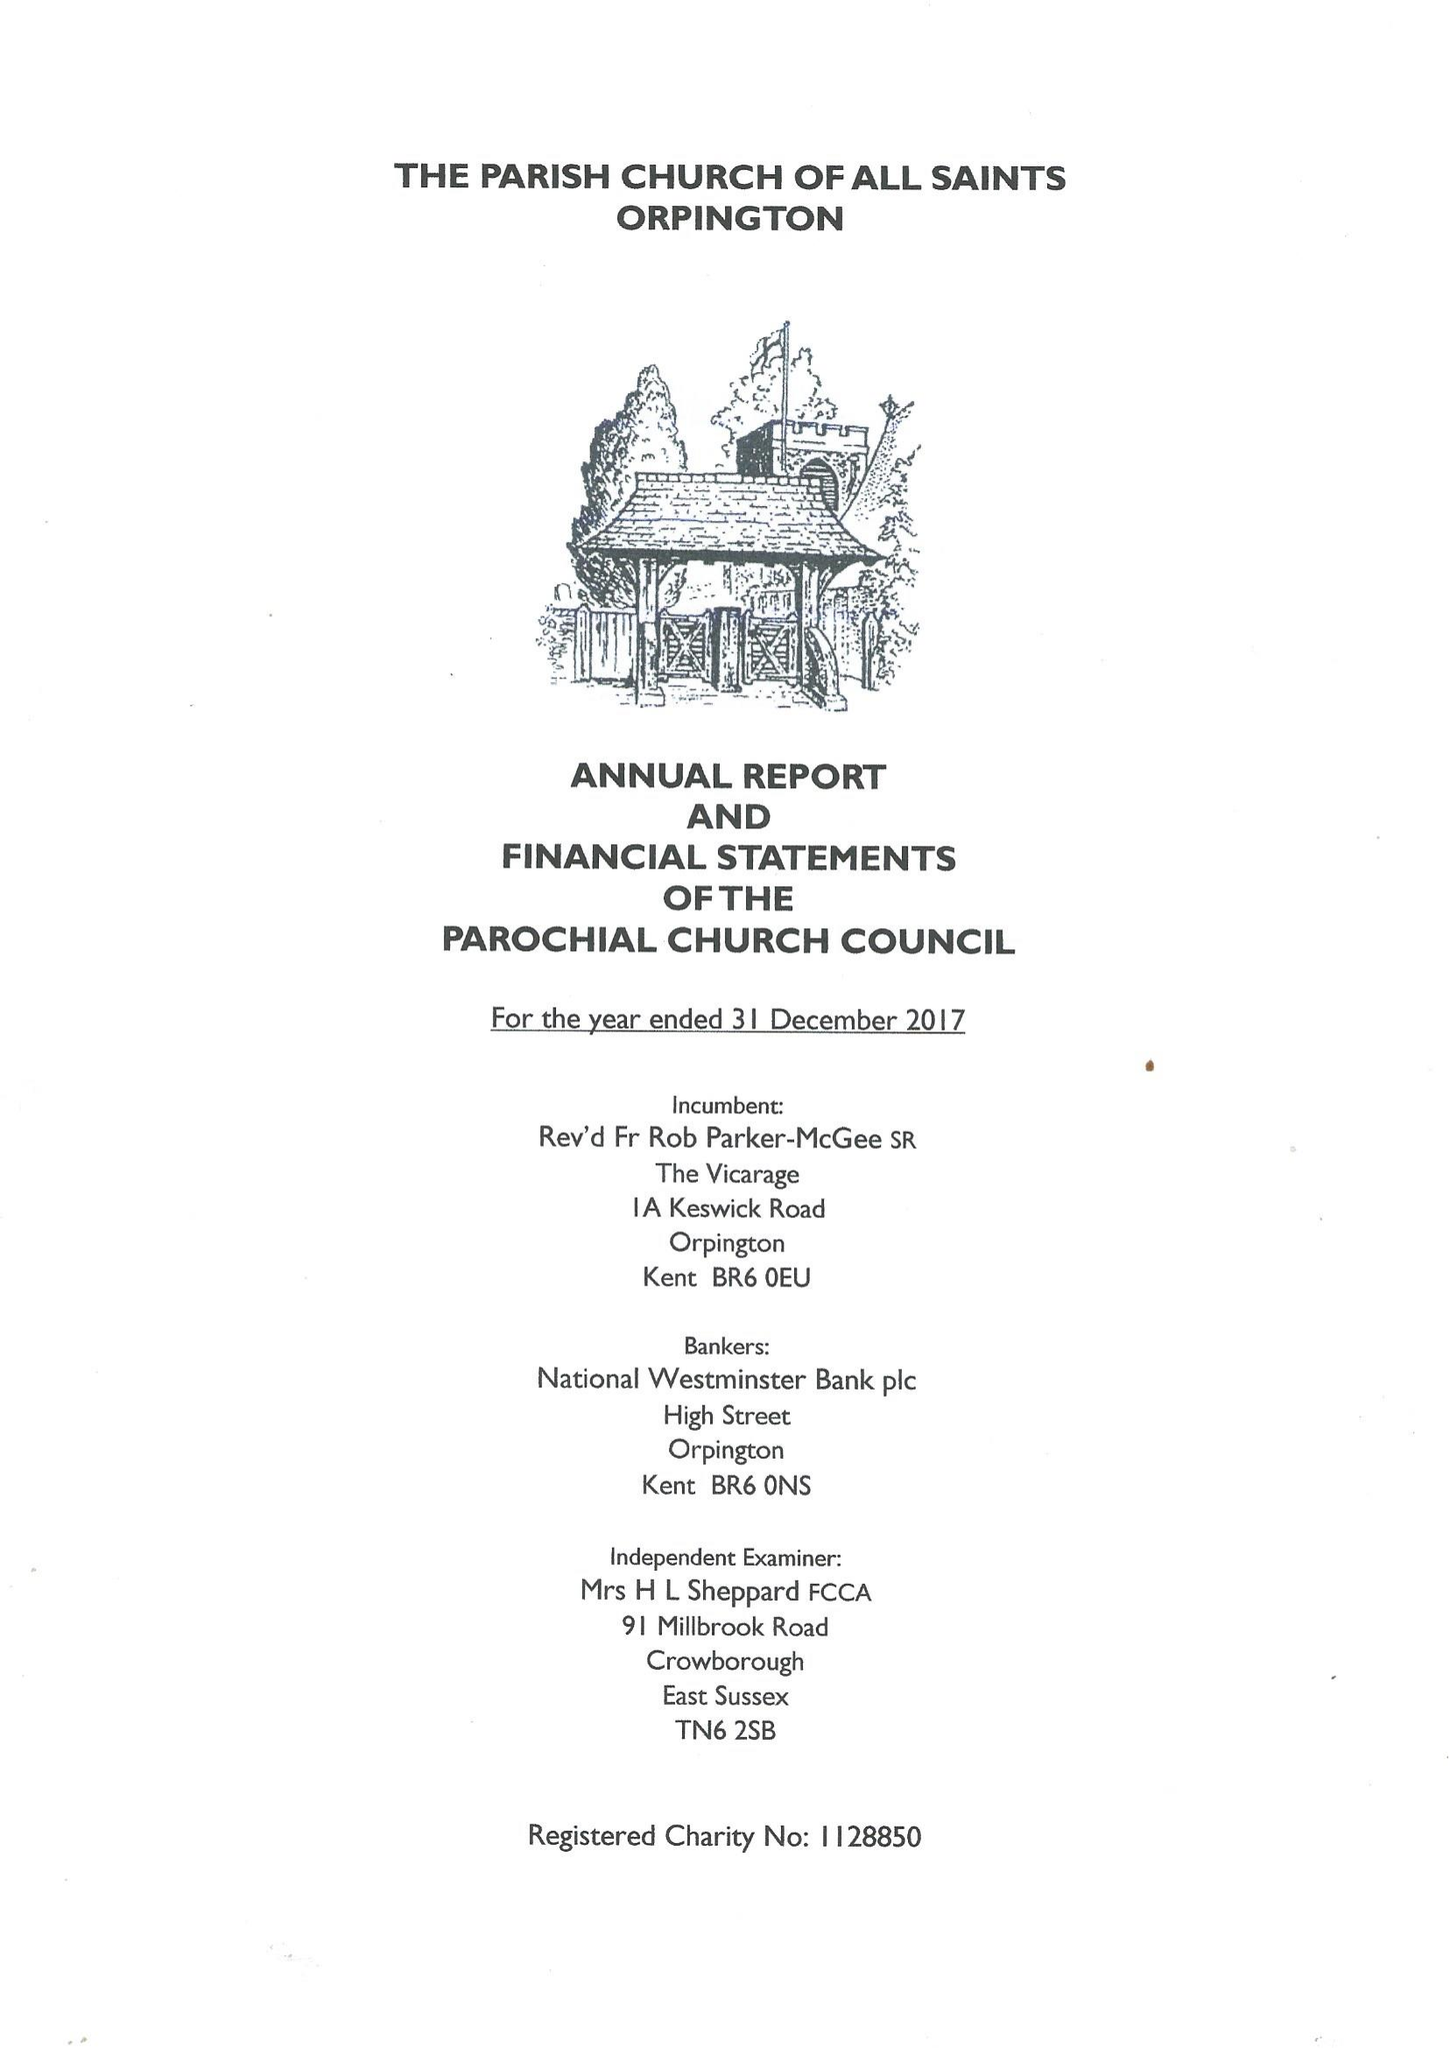What is the value for the address__postcode?
Answer the question using a single word or phrase. BR6 0QD 